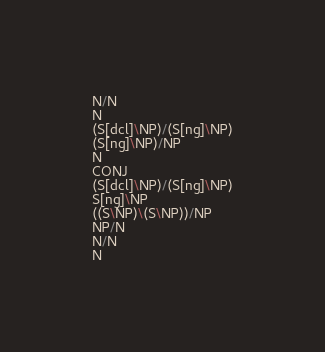<code> <loc_0><loc_0><loc_500><loc_500><_C_>N/N
N
(S[dcl]\NP)/(S[ng]\NP)
(S[ng]\NP)/NP
N
CONJ
(S[dcl]\NP)/(S[ng]\NP)
S[ng]\NP
((S\NP)\(S\NP))/NP
NP/N
N/N
N
</code> 